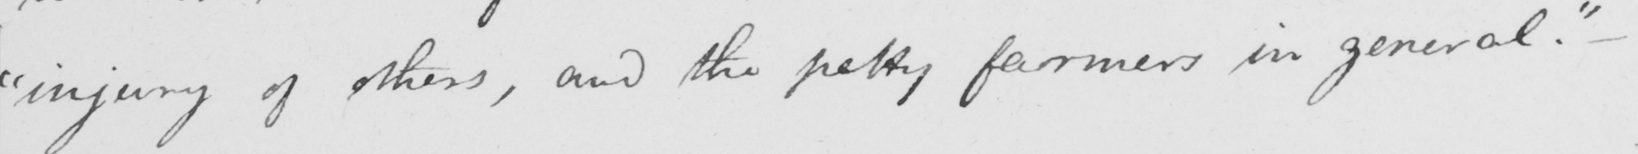Can you read and transcribe this handwriting? " injury of others , and the petty farmers in general . 